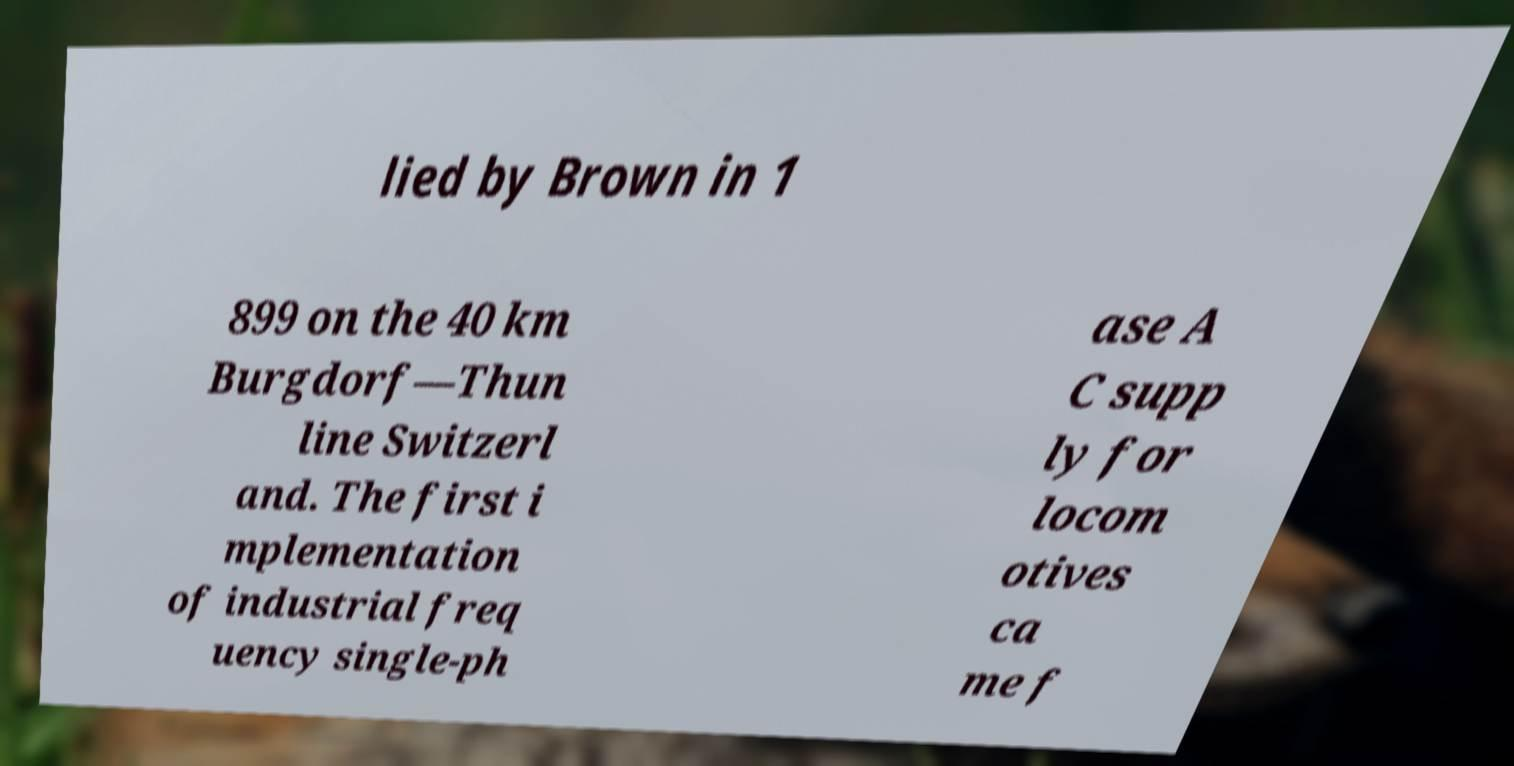For documentation purposes, I need the text within this image transcribed. Could you provide that? lied by Brown in 1 899 on the 40 km Burgdorf—Thun line Switzerl and. The first i mplementation of industrial freq uency single-ph ase A C supp ly for locom otives ca me f 